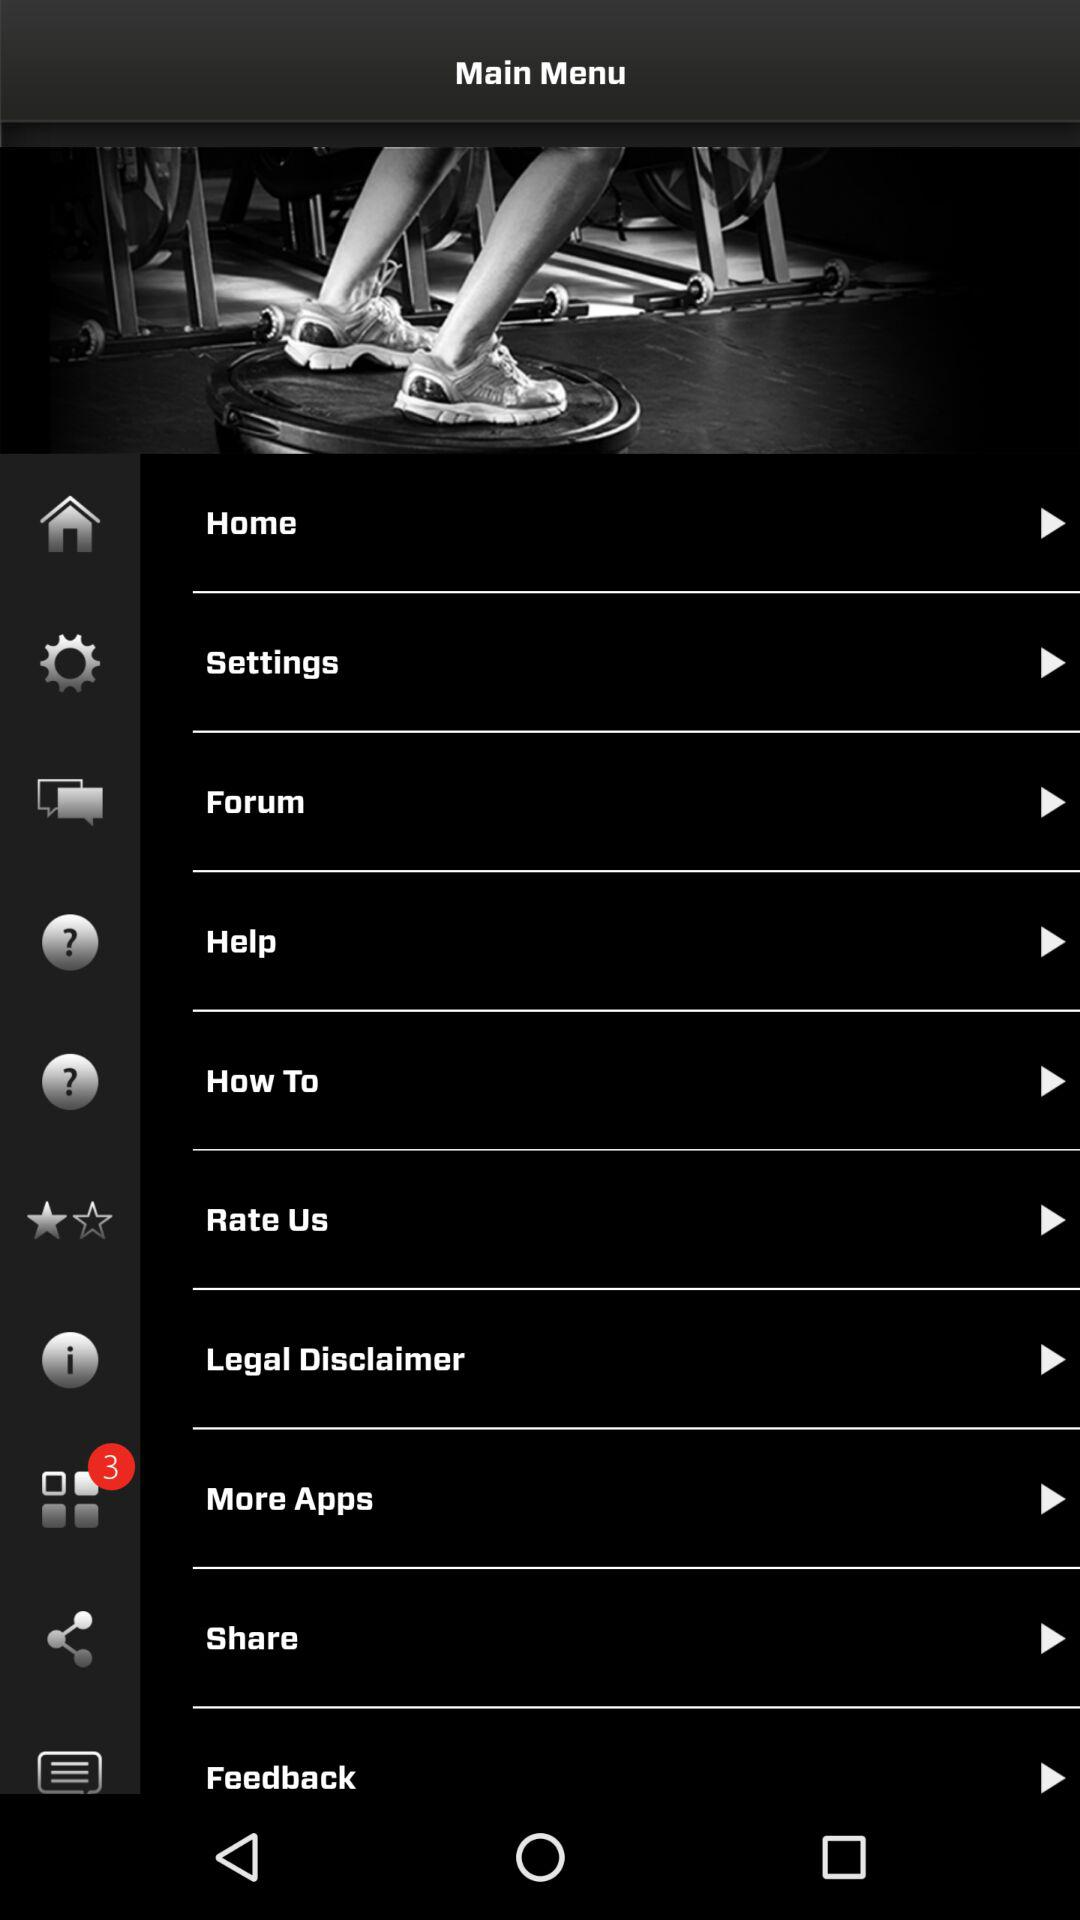How many new notifications are there? There are 3 new notifications. 